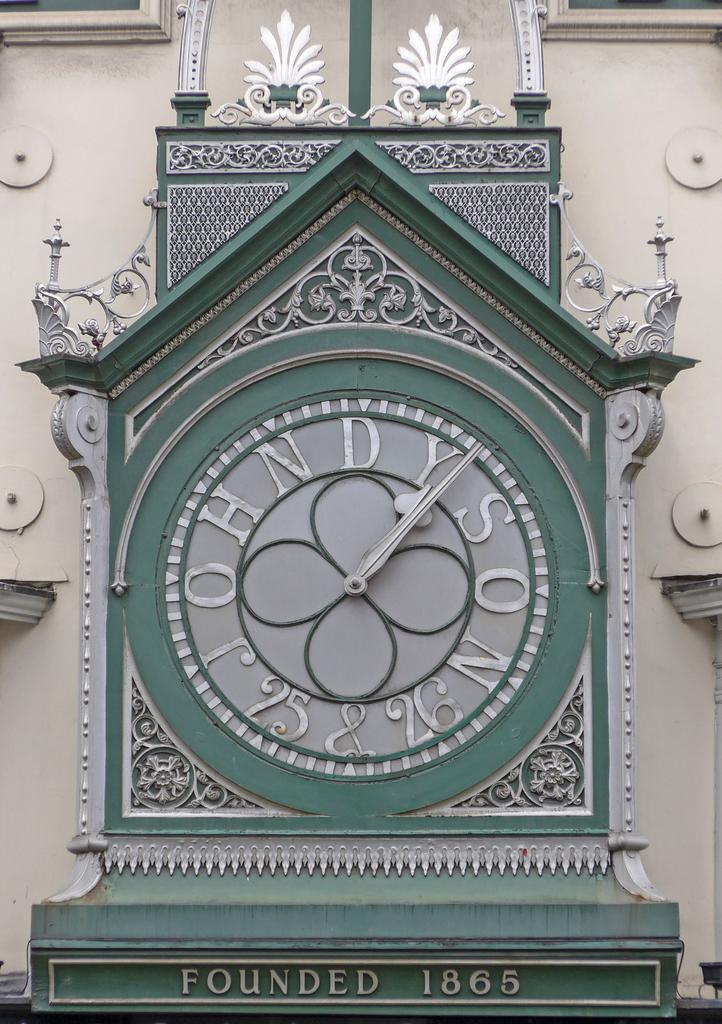<image>
Create a compact narrative representing the image presented. A classic green clock that was founded in 1865 